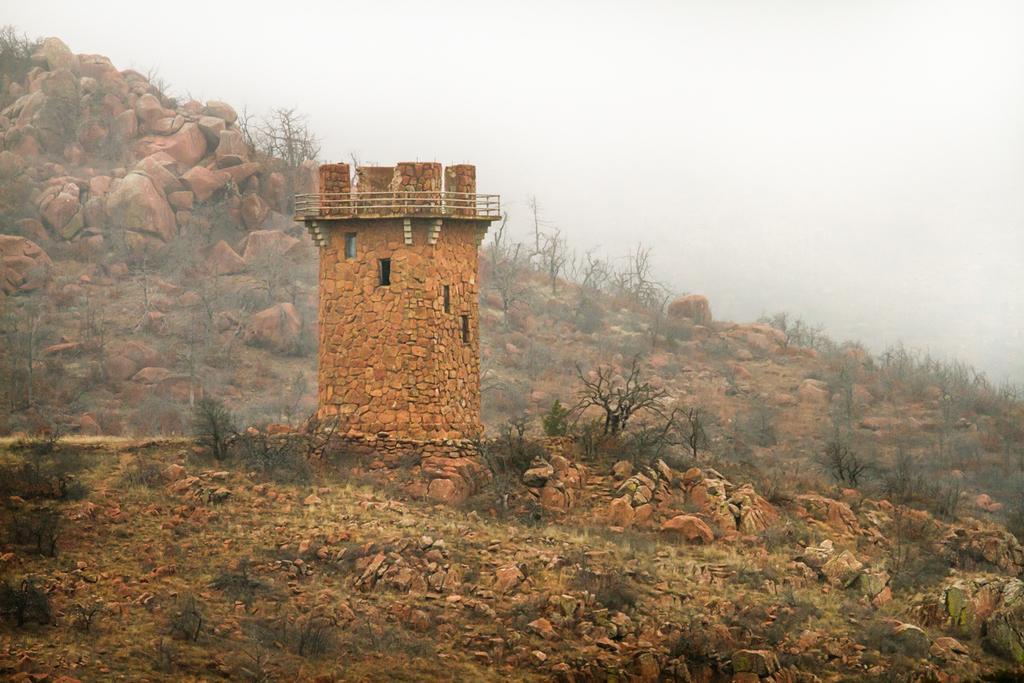In one or two sentences, can you explain what this image depicts? In the picture we can see a hill with rocks and dried plants and some construction with a rock and a railing on it and behind it, we can see a hill with rocks and some dried plants and in the background we can see a sky. 